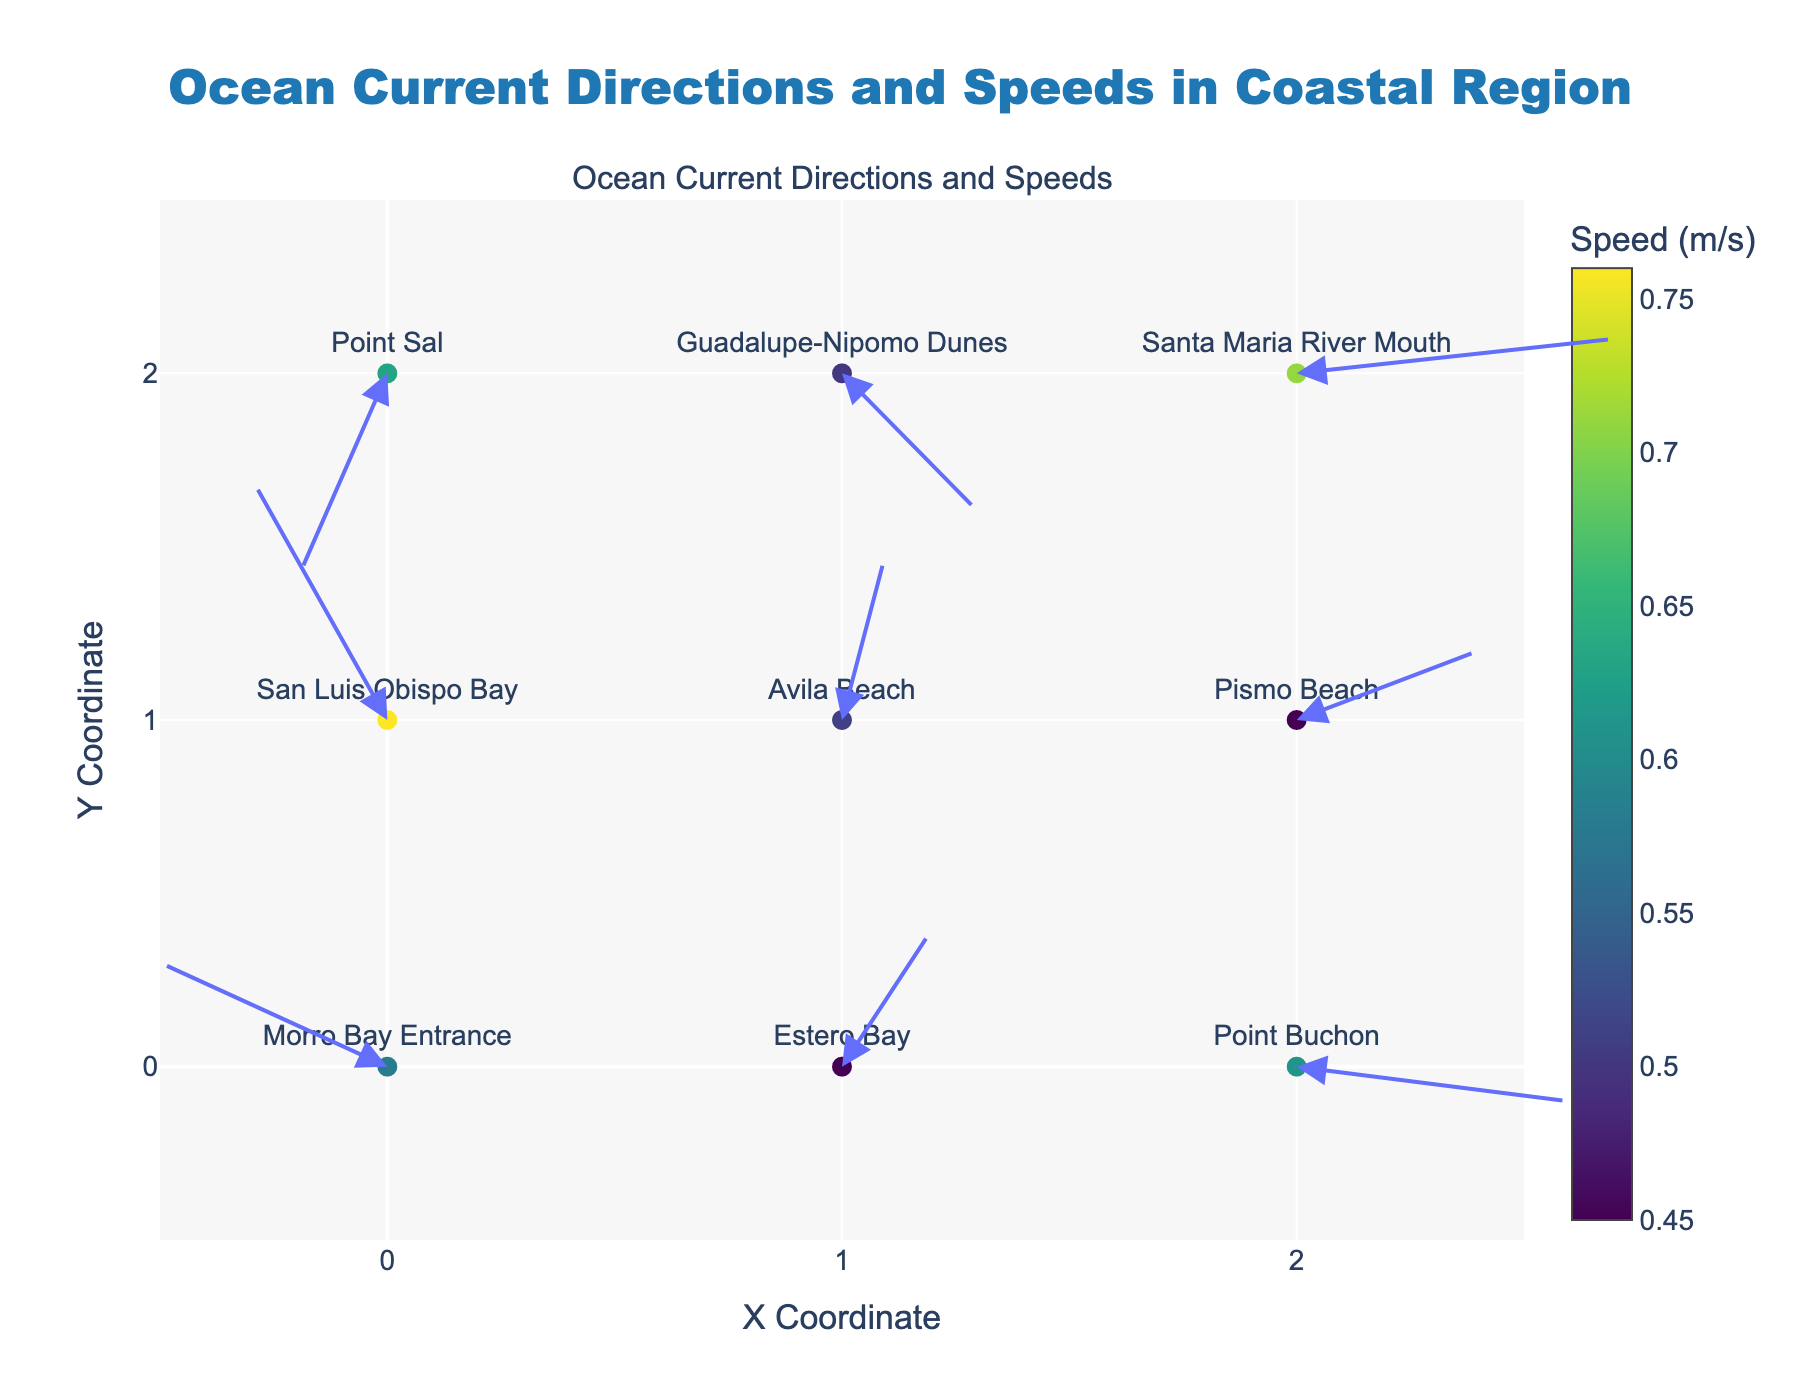What is the title of the plot? The title is located at the top of the plot and provides an overview of the subject of the visualization. The title in this case is "Ocean Current Directions and Speeds in Coastal Region".
Answer: Ocean Current Directions and Speeds in Coastal Region Which location has the highest current speed? By examining the color of the markers, which represents the speed, we can see that San Luis Obispo Bay has the highest speed, indicated by the darkest color shade.
Answer: San Luis Obispo Bay What is the speed of the current at Morro Bay Entrance? By hovering over the marker at the position (0, 0), the hovertext will reveal the speed. The speed is 0.58 m/s.
Answer: 0.58 m/s How many locations are displayed in the plot? The number of unique locations can be counted from the markers labeled on the plot. There are 9 different locations displayed.
Answer: 9 Which location has the direction vector pointing Southeast? The direction of the vectors is shown by the arrows. Looking for a vector pointing towards the bottom-right, which is the Southeast direction, we find that San Luis Obispo Bay has a direction vector pointing Southeast.
Answer: San Luis Obispo Bay Compare the current speeds between Estero Bay and Avila Beach. Which location has a greater speed? Estero Bay has a speed of 0.45 m/s, and Avila Beach has a speed of 0.51 m/s. Therefore, Avila Beach has a greater speed.
Answer: Avila Beach What is the average speed of ocean currents across all locations? To find the average, sum all the speeds (0.58 + 0.45 + 0.61 + 0.76 + 0.51 + 0.45 + 0.63 + 0.5 + 0.71) and divide by the number of locations (9). The total sum is 5.2, and 5.2/9 is approximately 0.58 m/s.
Answer: 0.58 m/s Which direction does the current at Point Sal flow? The direction can be inferred from the direction of the arrow at the position (0, 2). For Point Sal, the arrow points downward, indicating a South direction.
Answer: South How does the current speed at Point Buchon compare with Santa Maria River Mouth? Point Buchon has a speed of 0.61 m/s, while Santa Maria River Mouth has a speed of 0.71 m/s. Therefore, the current speed at Santa Maria River Mouth is higher than Point Buchon.
Answer: Santa Maria River Mouth is higher Which locations have their currents flowing towards the Northwest? Arrows pointing towards the top-left indicate a Northwest direction. By examining the arrows, Morro Bay Entrance and Point Sal have their currents flowing towards the Northwest.
Answer: Morro Bay Entrance and Point Sal 